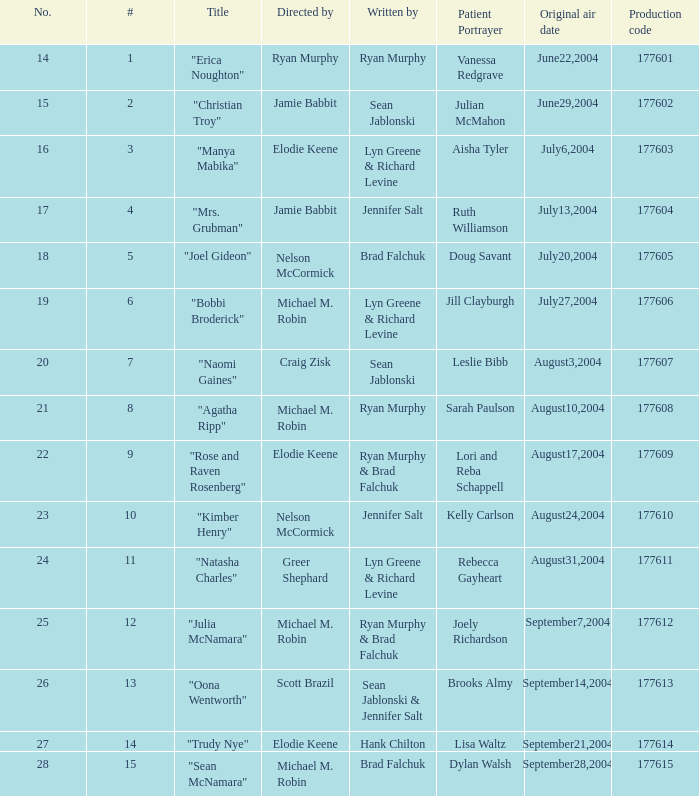Who is the author of episode 28? Brad Falchuk. 